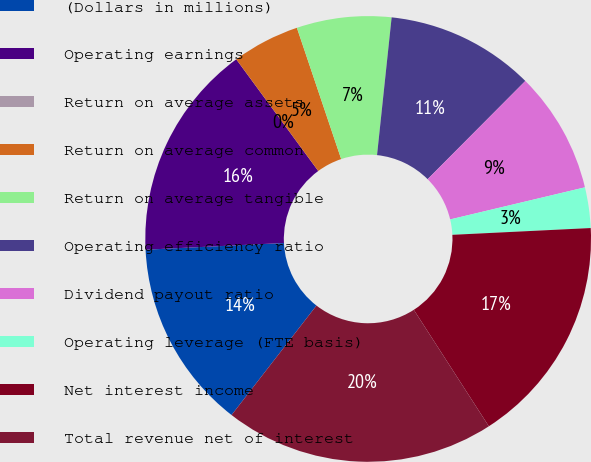<chart> <loc_0><loc_0><loc_500><loc_500><pie_chart><fcel>(Dollars in millions)<fcel>Operating earnings<fcel>Return on average assets<fcel>Return on average common<fcel>Return on average tangible<fcel>Operating efficiency ratio<fcel>Dividend payout ratio<fcel>Operating leverage (FTE basis)<fcel>Net interest income<fcel>Total revenue net of interest<nl><fcel>13.73%<fcel>15.69%<fcel>0.0%<fcel>4.9%<fcel>6.86%<fcel>10.78%<fcel>8.82%<fcel>2.94%<fcel>16.67%<fcel>19.61%<nl></chart> 